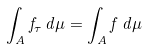<formula> <loc_0><loc_0><loc_500><loc_500>\int _ { A } f _ { \tau } \, d \mu = \int _ { A } f \, d \mu</formula> 